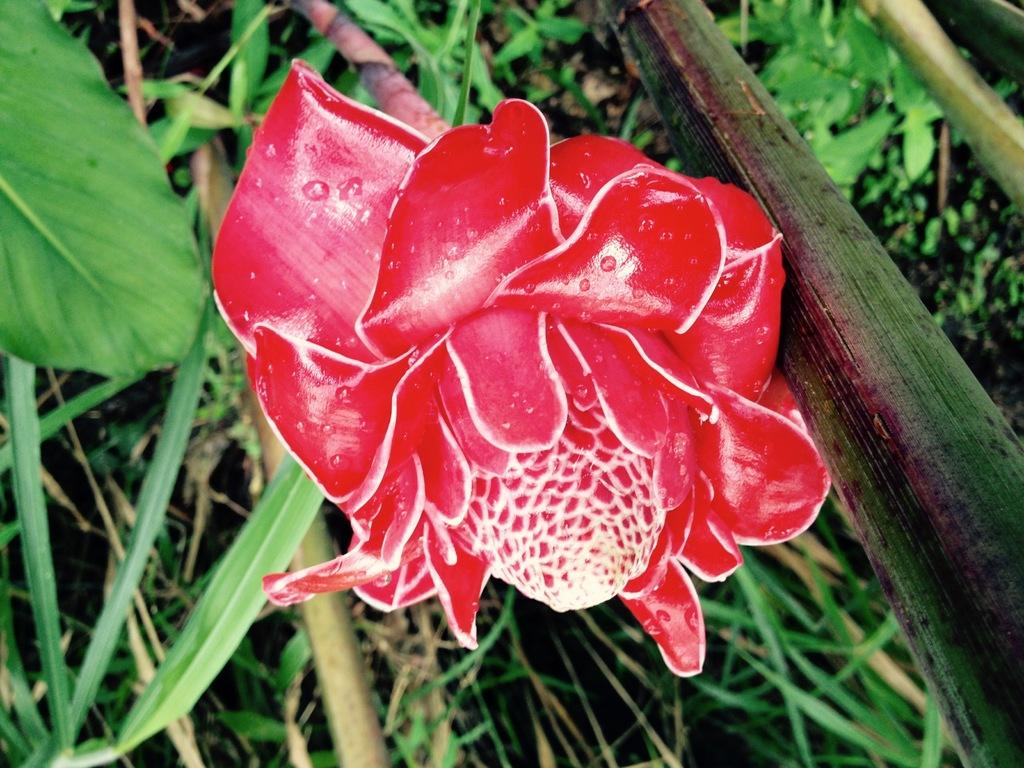What type of flower is in the image? There is a red color flower in the image. What can be seen in the background of the image? Grass, leaves, and stems are present in the background of the image. What is visible at the bottom of the image? The ground is visible in the image. How many snails can be seen crawling on the jar in the image? There is no jar or snails present in the image. 